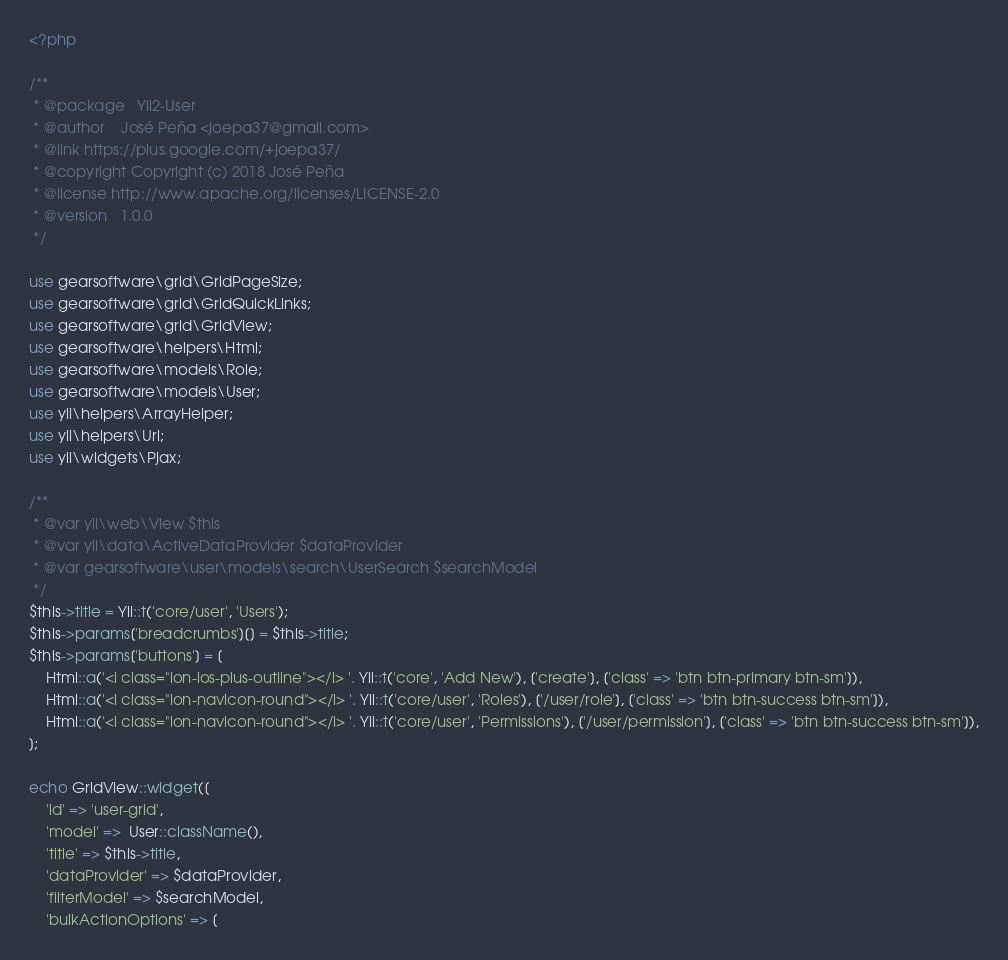<code> <loc_0><loc_0><loc_500><loc_500><_PHP_><?php

/**
 * @package   Yii2-User
 * @author    José Peña <joepa37@gmail.com>
 * @link https://plus.google.com/+joepa37/
 * @copyright Copyright (c) 2018 José Peña
 * @license http://www.apache.org/licenses/LICENSE-2.0
 * @version   1.0.0
 */

use gearsoftware\grid\GridPageSize;
use gearsoftware\grid\GridQuickLinks;
use gearsoftware\grid\GridView;
use gearsoftware\helpers\Html;
use gearsoftware\models\Role;
use gearsoftware\models\User;
use yii\helpers\ArrayHelper;
use yii\helpers\Url;
use yii\widgets\Pjax;

/**
 * @var yii\web\View $this
 * @var yii\data\ActiveDataProvider $dataProvider
 * @var gearsoftware\user\models\search\UserSearch $searchModel
 */
$this->title = Yii::t('core/user', 'Users');
$this->params['breadcrumbs'][] = $this->title;
$this->params['buttons'] = [
	Html::a('<i class="ion-ios-plus-outline"></i> '. Yii::t('core', 'Add New'), ['create'], ['class' => 'btn btn-primary btn-sm']),
	Html::a('<i class="ion-navicon-round"></i> '. Yii::t('core/user', 'Roles'), ['/user/role'], ['class' => 'btn btn-success btn-sm']),
	Html::a('<i class="ion-navicon-round"></i> '. Yii::t('core/user', 'Permissions'), ['/user/permission'], ['class' => 'btn btn-success btn-sm']),
];

echo GridView::widget([
	'id' => 'user-grid',
	'model' =>  User::className(),
	'title' => $this->title,
	'dataProvider' => $dataProvider,
	'filterModel' => $searchModel,
	'bulkActionOptions' => [</code> 